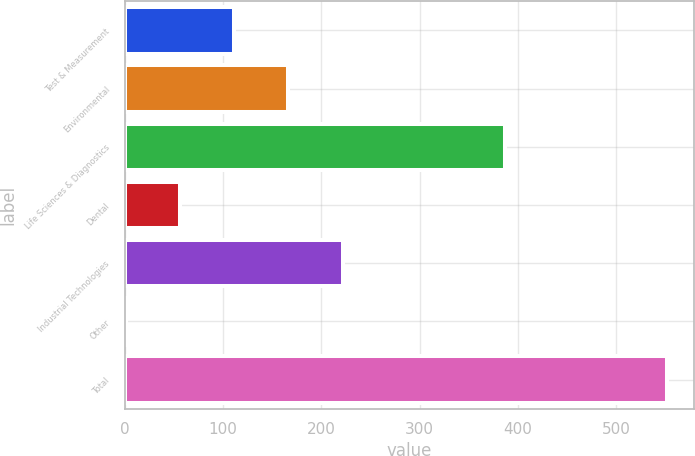<chart> <loc_0><loc_0><loc_500><loc_500><bar_chart><fcel>Test & Measurement<fcel>Environmental<fcel>Life Sciences & Diagnostics<fcel>Dental<fcel>Industrial Technologies<fcel>Other<fcel>Total<nl><fcel>111.66<fcel>166.64<fcel>386.7<fcel>56.68<fcel>221.62<fcel>1.7<fcel>551.5<nl></chart> 